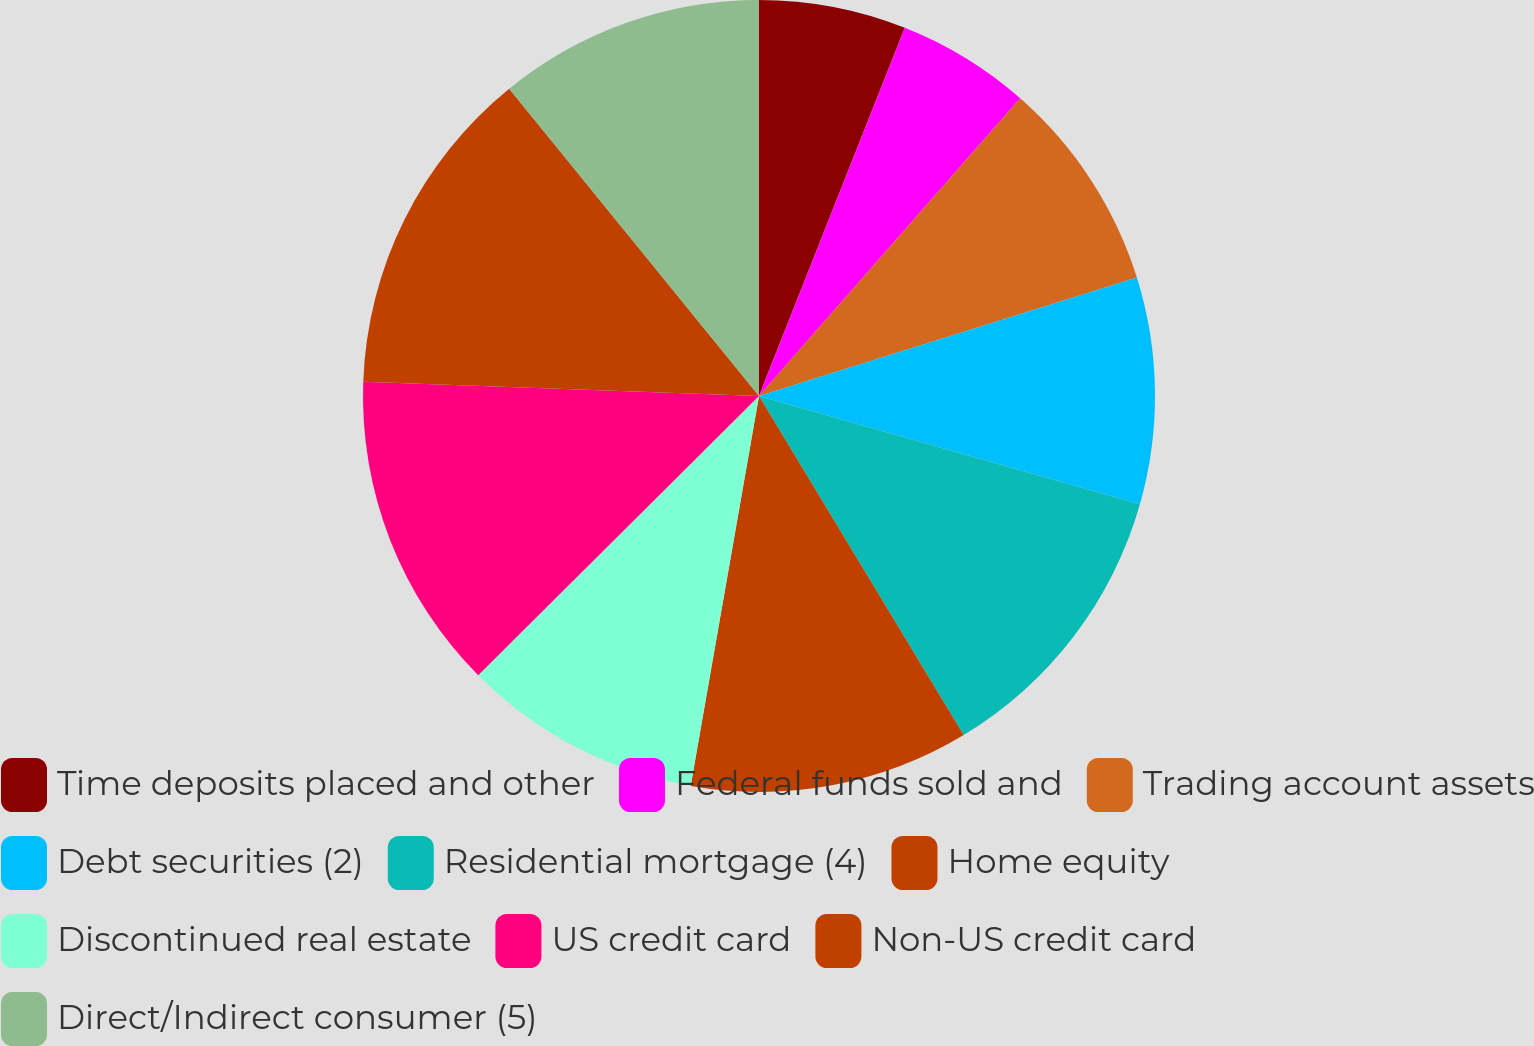Convert chart. <chart><loc_0><loc_0><loc_500><loc_500><pie_chart><fcel>Time deposits placed and other<fcel>Federal funds sold and<fcel>Trading account assets<fcel>Debt securities (2)<fcel>Residential mortgage (4)<fcel>Home equity<fcel>Discontinued real estate<fcel>US credit card<fcel>Non-US credit card<fcel>Direct/Indirect consumer (5)<nl><fcel>6.0%<fcel>5.46%<fcel>8.7%<fcel>9.24%<fcel>11.94%<fcel>11.4%<fcel>9.78%<fcel>13.02%<fcel>13.56%<fcel>10.86%<nl></chart> 